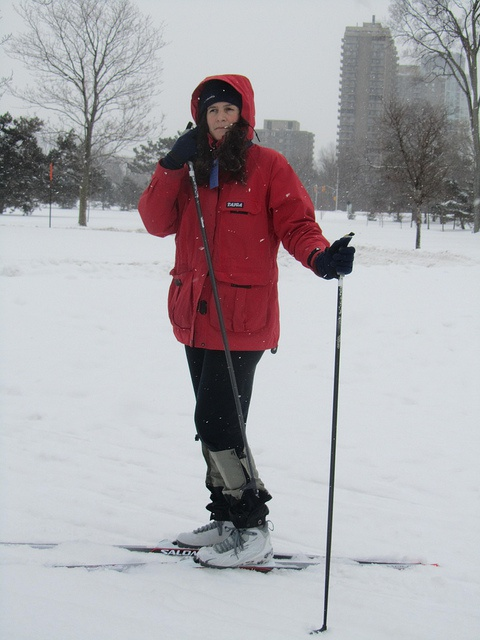Describe the objects in this image and their specific colors. I can see people in lightgray, maroon, black, brown, and gray tones and skis in lightgray, darkgray, and gray tones in this image. 